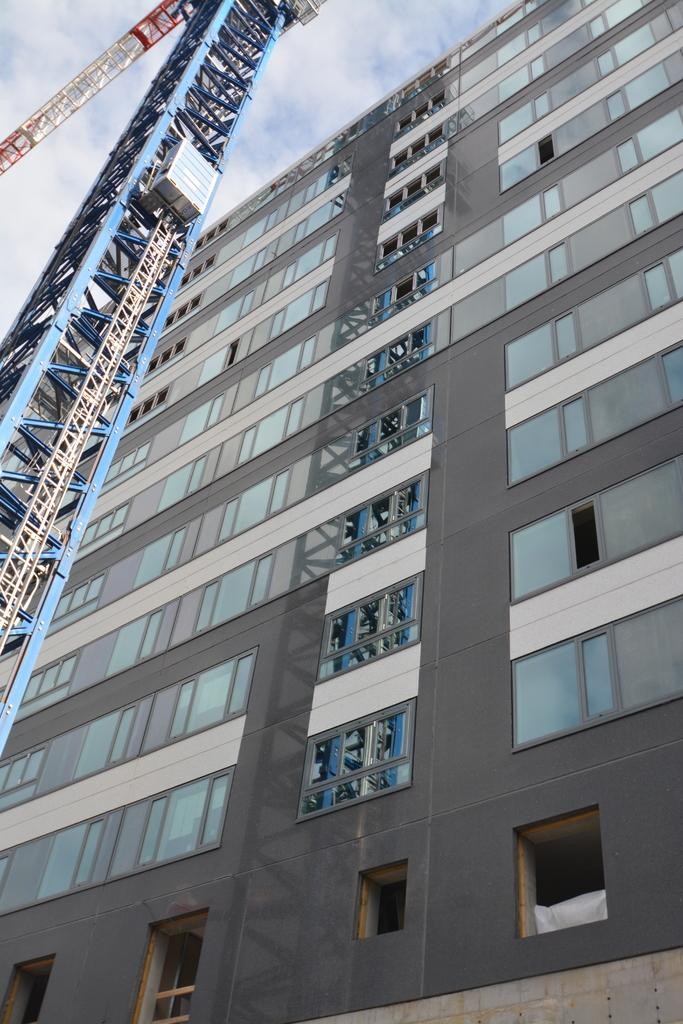What type of structure is present in the image? There is a building in the image. What additional feature can be seen on the building? There is a tower in the image. What is visible in the sky at the top of the image? There are clouds visible at the top of the image. What type of cream is being used as a punishment in the image? There is no cream or punishment present in the image; it features a building with a tower and clouds in the sky. Can you see any crackers in the image? There are no crackers present in the image. 